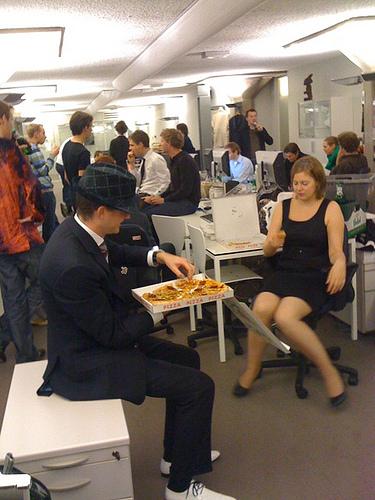What is the man eating?
Concise answer only. Pizza. What is the woman doing?
Quick response, please. Eating. What color hat is the man wearing?
Concise answer only. Black. 